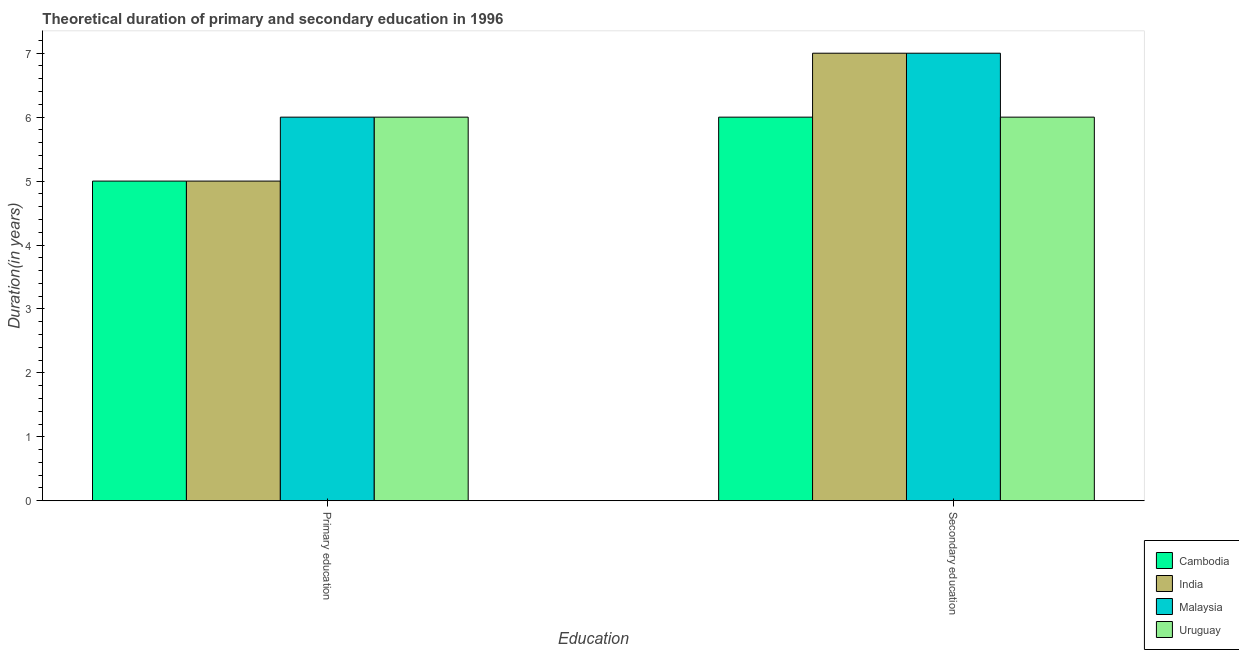How many different coloured bars are there?
Offer a terse response. 4. How many groups of bars are there?
Ensure brevity in your answer.  2. Are the number of bars per tick equal to the number of legend labels?
Give a very brief answer. Yes. Are the number of bars on each tick of the X-axis equal?
Your answer should be compact. Yes. How many bars are there on the 2nd tick from the left?
Provide a short and direct response. 4. How many bars are there on the 2nd tick from the right?
Provide a short and direct response. 4. What is the label of the 2nd group of bars from the left?
Offer a terse response. Secondary education. Across all countries, what is the maximum duration of secondary education?
Offer a very short reply. 7. In which country was the duration of secondary education maximum?
Provide a succinct answer. India. In which country was the duration of primary education minimum?
Ensure brevity in your answer.  Cambodia. What is the total duration of secondary education in the graph?
Your answer should be compact. 26. What is the difference between the duration of primary education in India and that in Uruguay?
Provide a short and direct response. -1. What is the difference between the duration of primary education in Uruguay and the duration of secondary education in Malaysia?
Keep it short and to the point. -1. What is the average duration of secondary education per country?
Make the answer very short. 6.5. What is the difference between the duration of secondary education and duration of primary education in Uruguay?
Keep it short and to the point. 0. Is the duration of primary education in India less than that in Malaysia?
Offer a very short reply. Yes. In how many countries, is the duration of secondary education greater than the average duration of secondary education taken over all countries?
Your response must be concise. 2. What does the 1st bar from the left in Primary education represents?
Provide a short and direct response. Cambodia. What does the 2nd bar from the right in Secondary education represents?
Offer a very short reply. Malaysia. How many bars are there?
Keep it short and to the point. 8. How many countries are there in the graph?
Offer a very short reply. 4. Does the graph contain any zero values?
Keep it short and to the point. No. How many legend labels are there?
Make the answer very short. 4. How are the legend labels stacked?
Your answer should be very brief. Vertical. What is the title of the graph?
Offer a very short reply. Theoretical duration of primary and secondary education in 1996. Does "Guyana" appear as one of the legend labels in the graph?
Keep it short and to the point. No. What is the label or title of the X-axis?
Keep it short and to the point. Education. What is the label or title of the Y-axis?
Provide a succinct answer. Duration(in years). What is the Duration(in years) of Cambodia in Primary education?
Ensure brevity in your answer.  5. What is the Duration(in years) in India in Primary education?
Offer a terse response. 5. What is the Duration(in years) in Cambodia in Secondary education?
Provide a short and direct response. 6. What is the Duration(in years) of India in Secondary education?
Make the answer very short. 7. What is the Duration(in years) in Malaysia in Secondary education?
Ensure brevity in your answer.  7. Across all Education, what is the maximum Duration(in years) in Cambodia?
Your answer should be very brief. 6. Across all Education, what is the maximum Duration(in years) of India?
Your response must be concise. 7. Across all Education, what is the maximum Duration(in years) in Malaysia?
Your answer should be very brief. 7. Across all Education, what is the minimum Duration(in years) of Malaysia?
Provide a short and direct response. 6. What is the total Duration(in years) in Uruguay in the graph?
Ensure brevity in your answer.  12. What is the difference between the Duration(in years) of Cambodia in Primary education and the Duration(in years) of India in Secondary education?
Your response must be concise. -2. What is the difference between the Duration(in years) in India in Primary education and the Duration(in years) in Malaysia in Secondary education?
Provide a succinct answer. -2. What is the average Duration(in years) in India per Education?
Your answer should be very brief. 6. What is the average Duration(in years) of Malaysia per Education?
Your answer should be compact. 6.5. What is the difference between the Duration(in years) of Cambodia and Duration(in years) of Uruguay in Primary education?
Your answer should be very brief. -1. What is the difference between the Duration(in years) in India and Duration(in years) in Malaysia in Primary education?
Keep it short and to the point. -1. What is the difference between the Duration(in years) of India and Duration(in years) of Uruguay in Primary education?
Keep it short and to the point. -1. What is the difference between the Duration(in years) in Cambodia and Duration(in years) in India in Secondary education?
Your response must be concise. -1. What is the difference between the Duration(in years) in Cambodia and Duration(in years) in Malaysia in Secondary education?
Provide a succinct answer. -1. What is the difference between the Duration(in years) of Cambodia and Duration(in years) of Uruguay in Secondary education?
Provide a succinct answer. 0. What is the difference between the Duration(in years) of India and Duration(in years) of Malaysia in Secondary education?
Offer a terse response. 0. What is the ratio of the Duration(in years) in Cambodia in Primary education to that in Secondary education?
Ensure brevity in your answer.  0.83. What is the difference between the highest and the second highest Duration(in years) of Cambodia?
Offer a very short reply. 1. What is the difference between the highest and the second highest Duration(in years) of India?
Make the answer very short. 2. What is the difference between the highest and the second highest Duration(in years) of Uruguay?
Offer a terse response. 0. What is the difference between the highest and the lowest Duration(in years) of India?
Your answer should be compact. 2. What is the difference between the highest and the lowest Duration(in years) in Uruguay?
Ensure brevity in your answer.  0. 